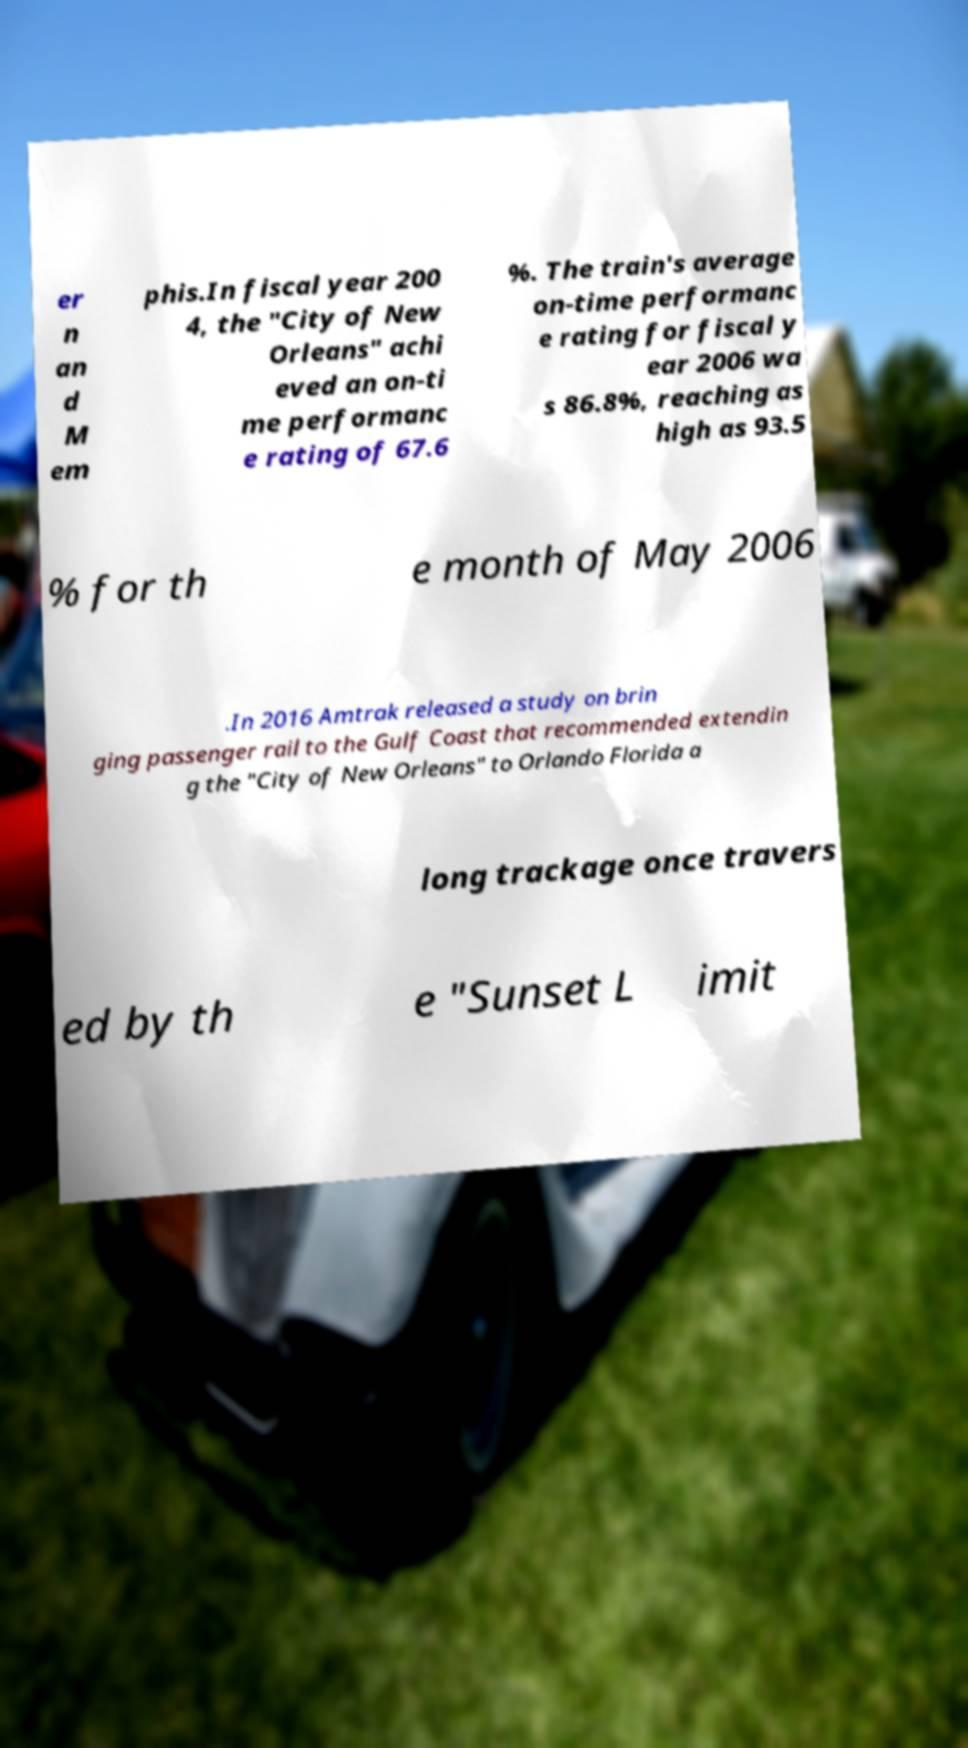Please identify and transcribe the text found in this image. er n an d M em phis.In fiscal year 200 4, the "City of New Orleans" achi eved an on-ti me performanc e rating of 67.6 %. The train's average on-time performanc e rating for fiscal y ear 2006 wa s 86.8%, reaching as high as 93.5 % for th e month of May 2006 .In 2016 Amtrak released a study on brin ging passenger rail to the Gulf Coast that recommended extendin g the "City of New Orleans" to Orlando Florida a long trackage once travers ed by th e "Sunset L imit 